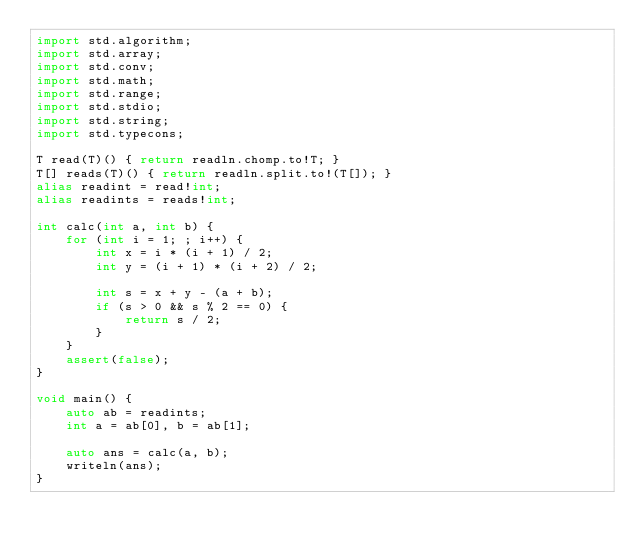Convert code to text. <code><loc_0><loc_0><loc_500><loc_500><_D_>import std.algorithm;
import std.array;
import std.conv;
import std.math;
import std.range;
import std.stdio;
import std.string;
import std.typecons;

T read(T)() { return readln.chomp.to!T; }
T[] reads(T)() { return readln.split.to!(T[]); }
alias readint = read!int;
alias readints = reads!int;

int calc(int a, int b) {
    for (int i = 1; ; i++) {
        int x = i * (i + 1) / 2;
        int y = (i + 1) * (i + 2) / 2;

        int s = x + y - (a + b);
        if (s > 0 && s % 2 == 0) {
            return s / 2;
        }
    }
    assert(false);
}

void main() {
    auto ab = readints;
    int a = ab[0], b = ab[1];

    auto ans = calc(a, b);
    writeln(ans);
}
</code> 